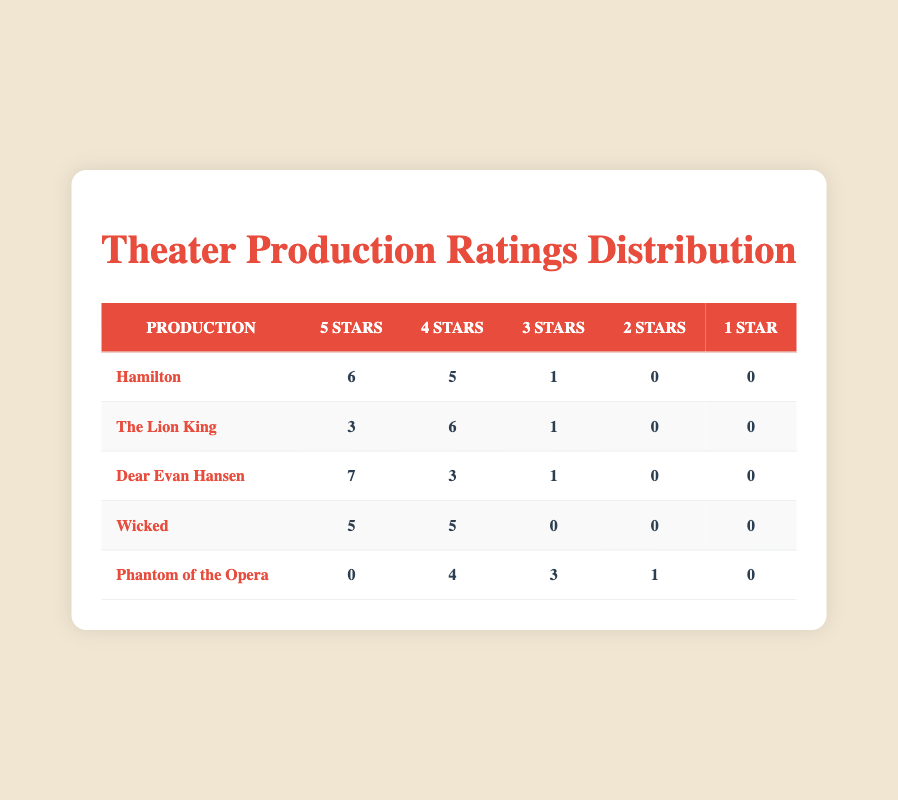What production received the highest number of 5-star ratings? Referring to the table, "Dear Evan Hansen" has the highest number of 5-star ratings with 7.
Answer: Dear Evan Hansen How many total ratings were recorded for "Wicked"? The ratings for "Wicked" are as follows: 5 (5-star) + 5 (4-star) + 0 (3-star) + 0 (2-star) + 0 (1-star) = 10 total ratings.
Answer: 10 Which production had the lowest customer satisfaction overall? "Phantom of the Opera" received 4 ratings of 4 stars, 3 ratings of 3 stars, and 1 rating of 2 stars. In total, it has 8 ratings, where 4 ratings are less than 4 stars, compared to others.
Answer: Phantom of the Opera Is it true that "The Lion King" received at least one 5-star rating? Yes, the data shows that "The Lion King" received 3 ratings of 5 stars, confirming it received at least one 5-star rating.
Answer: Yes What is the average rating received by "Hamilton"? To find the average rating for "Hamilton," we sum the ratings: (5*6 + 4*5 + 3*1 + 0*0 + 0*0) / (6 + 5 + 1 + 0 + 0) = 4.5. The total ratings are 12, and the total points are 54, thus average is 54/12 = 4.5.
Answer: 4.5 How many productions received more than 5 ratings of 4 stars? Checking the productions: "Hamilton" received 5, "The Lion King" 6, "Dear Evan Hansen" 3, "Wicked" 5, and "Phantom of the Opera" 4. The only production meeting the criteria is "The Lion King."
Answer: 1 Which production had the highest total number of ratings across all categories? By adding ratings for each production: Hamilton (12), The Lion King (10), Dear Evan Hansen (11), Wicked (10), and Phantom of the Opera (8), "Hamilton" has the highest at 12 ratings.
Answer: Hamilton Did "Wicked" receive any 1-star ratings? No, "Wicked" did not receive any 1-star ratings as indicated by the value of 0 in that column.
Answer: No 